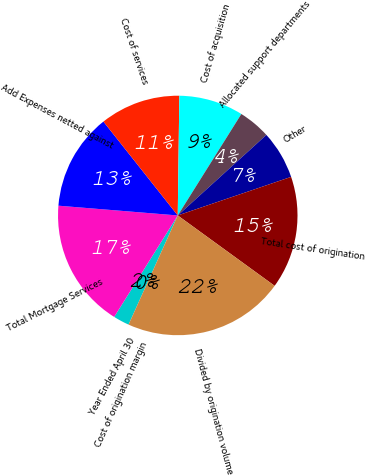Convert chart. <chart><loc_0><loc_0><loc_500><loc_500><pie_chart><fcel>Year Ended April 30<fcel>Total Mortgage Services<fcel>Add Expenses netted against<fcel>Cost of services<fcel>Cost of acquisition<fcel>Allocated support departments<fcel>Other<fcel>Total cost of origination<fcel>Divided by origination volume<fcel>Cost of origination margin<nl><fcel>2.17%<fcel>17.39%<fcel>13.04%<fcel>10.87%<fcel>8.7%<fcel>4.35%<fcel>6.52%<fcel>15.22%<fcel>21.74%<fcel>0.0%<nl></chart> 